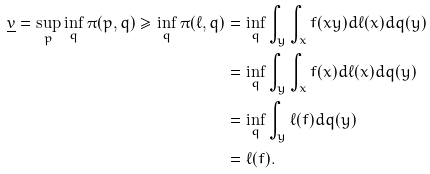Convert formula to latex. <formula><loc_0><loc_0><loc_500><loc_500>\underline { v } = \sup _ { p } \inf _ { q } \pi ( p , q ) \geq \inf _ { q } \pi ( \ell , q ) & = \inf _ { q } \int _ { y } \int _ { x } f ( x y ) d \ell ( x ) d q ( y ) \\ & = \inf _ { q } \int _ { y } \int _ { x } f ( x ) d \ell ( x ) d q ( y ) \\ & = \inf _ { q } \int _ { y } \ell ( f ) d q ( y ) \\ & = \ell ( f ) .</formula> 